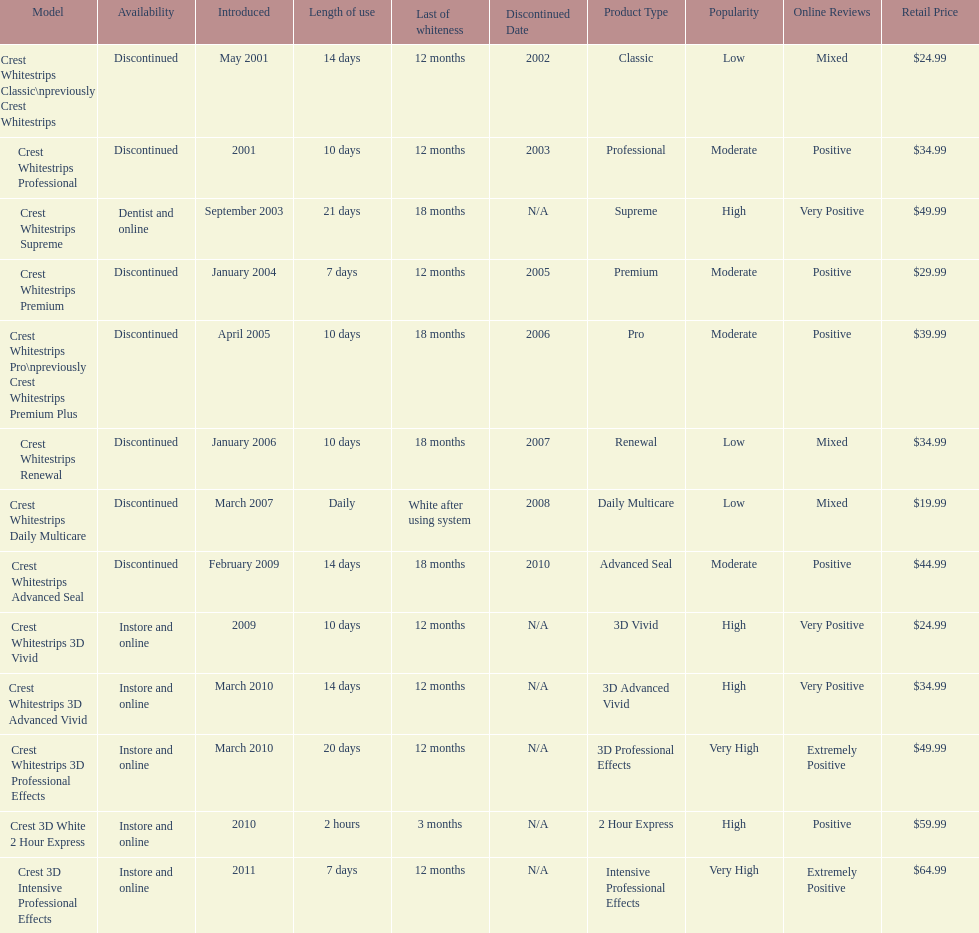Which model has the highest 'length of use' to 'last of whiteness' ratio? Crest Whitestrips Supreme. 